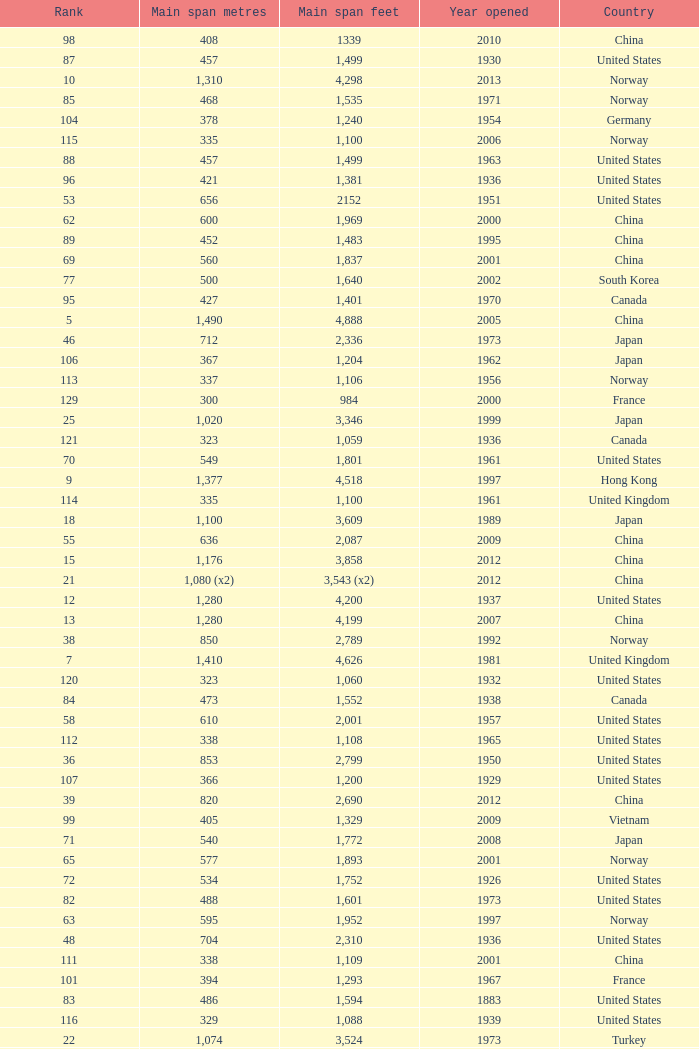Can you parse all the data within this table? {'header': ['Rank', 'Main span metres', 'Main span feet', 'Year opened', 'Country'], 'rows': [['98', '408', '1339', '2010', 'China'], ['87', '457', '1,499', '1930', 'United States'], ['10', '1,310', '4,298', '2013', 'Norway'], ['85', '468', '1,535', '1971', 'Norway'], ['104', '378', '1,240', '1954', 'Germany'], ['115', '335', '1,100', '2006', 'Norway'], ['88', '457', '1,499', '1963', 'United States'], ['96', '421', '1,381', '1936', 'United States'], ['53', '656', '2152', '1951', 'United States'], ['62', '600', '1,969', '2000', 'China'], ['89', '452', '1,483', '1995', 'China'], ['69', '560', '1,837', '2001', 'China'], ['77', '500', '1,640', '2002', 'South Korea'], ['95', '427', '1,401', '1970', 'Canada'], ['5', '1,490', '4,888', '2005', 'China'], ['46', '712', '2,336', '1973', 'Japan'], ['106', '367', '1,204', '1962', 'Japan'], ['113', '337', '1,106', '1956', 'Norway'], ['129', '300', '984', '2000', 'France'], ['25', '1,020', '3,346', '1999', 'Japan'], ['121', '323', '1,059', '1936', 'Canada'], ['70', '549', '1,801', '1961', 'United States'], ['9', '1,377', '4,518', '1997', 'Hong Kong'], ['114', '335', '1,100', '1961', 'United Kingdom'], ['18', '1,100', '3,609', '1989', 'Japan'], ['55', '636', '2,087', '2009', 'China'], ['15', '1,176', '3,858', '2012', 'China'], ['21', '1,080 (x2)', '3,543 (x2)', '2012', 'China'], ['12', '1,280', '4,200', '1937', 'United States'], ['13', '1,280', '4,199', '2007', 'China'], ['38', '850', '2,789', '1992', 'Norway'], ['7', '1,410', '4,626', '1981', 'United Kingdom'], ['120', '323', '1,060', '1932', 'United States'], ['84', '473', '1,552', '1938', 'Canada'], ['58', '610', '2,001', '1957', 'United States'], ['112', '338', '1,108', '1965', 'United States'], ['36', '853', '2,799', '1950', 'United States'], ['107', '366', '1,200', '1929', 'United States'], ['39', '820', '2,690', '2012', 'China'], ['99', '405', '1,329', '2009', 'Vietnam'], ['71', '540', '1,772', '2008', 'Japan'], ['65', '577', '1,893', '2001', 'Norway'], ['72', '534', '1,752', '1926', 'United States'], ['82', '488', '1,601', '1973', 'United States'], ['63', '595', '1,952', '1997', 'Norway'], ['48', '704', '2,310', '1936', 'United States'], ['111', '338', '1,109', '2001', 'China'], ['101', '394', '1,293', '1967', 'France'], ['83', '486', '1,594', '1883', 'United States'], ['116', '329', '1,088', '1939', 'United States'], ['22', '1,074', '3,524', '1973', 'Turkey'], ['119', '325', '1,066', '1981', 'Norway'], ['78', '497', '1,631', '1924', 'United States'], ['109', '350', '1,148', '2006', 'China'], ['86', '465', '1,526', '1977', 'Japan'], ['40', '770', '2,526', '1983', 'Japan'], ['20', '1,088', '3,570', '2009', 'China'], ['90', '450', '1,476', '1997', 'China'], ['67', '564', '1,850', '1929', 'United States Canada'], ['64', '580', '1,903', '2003', 'China'], ['57', '616', '2,021', '2009', 'China'], ['130', '300', '984', '2000', 'South Korea'], ['80', '488', '1,601', '1969', 'United States'], ['92', '446', '1,463', '1997', 'Norway'], ['60', '600', '1,969', '1970', 'Denmark'], ['127', '300', '985', '1961', 'Canada'], ['31', '940', '3,084', '1988', 'Japan'], ['76', '500', '1,640', '1965', 'Germany'], ['16', '1,158', '3,799', '1957', 'United States'], ['37', '853', '2,799', '2007', 'United States'], ['74', '525', '1,722', '1977', 'Norway'], ['17', '1,108', '3,635', '2008', 'China'], ['33', '900', '2,953', '2009', 'China'], ['3', '1,624', '5,328', '1998', 'Denmark'], ['45', '712', '2,336', '1967', 'Venezuela'], ['14', '1,210', '3,970', '1997', 'Sweden'], ['24', '1,030', '3,379', '1999', 'Japan'], ['59', '608', '1,995', '1959', 'France'], ['103', '385', '1,263', '2013', 'United States'], ['66', '570', '1,870', '1993', 'Japan'], ['79', '488', '1,601', '1903', 'United States'], ['28', '990', '3,248', '1988', 'Japan'], ['8', '1,385', '4,544', '1999', 'China'], ['32', '900', '2,953', '1996', 'China'], ['97', '417', '1,368', '1966', 'Sweden'], ['52', '656', '2,152', '1968', 'United States'], ['126', '308', '1,010', '1849', 'United States'], ['68', '560', '1,837', '1988', 'Japan'], ['47', '704', '2,310', '1936', 'United States'], ['102', '390', '1,280', '1964', 'Uzbekistan'], ['42', '750', '2,461', '2000', 'Kazakhstan'], ['29', '988', '3,241', '1966', 'United Kingdom'], ['91', '448', '1,470', '1909', 'United States'], ['81', '488', '1,601', '1952', 'United States'], ['4', '1,545', '5,069', '2012', 'South Korea'], ['54', '648', '2,126', '1999', 'China'], ['61', '600', '1,969', '1999', 'Japan'], ['41', '750', '2,461', '2000', 'Japan'], ['44', '720', '2,362', '1998', 'Japan'], ['75', '520', '1,706', '1983', 'Democratic Republic of the Congo'], ['51', '668', '2,192', '1969', 'Canada'], ['73', '525', '1,722', '1972', 'Norway'], ['128', '300', '984', '1987', 'Japan'], ['19', '1,090', '3,576', '1988', 'Turkey'], ['35', '876', '2,874', '1985', 'Japan'], ['34', '888', '2,913', '1997', 'China'], ['105', '368', '1,207', '1931', 'United States'], ['110', '340', '1,115', '1926', 'Brazil'], ['50', '677', '2,221', '2001', 'Norway'], ['124', '320', '1,050', '2011', 'Peru'], ['125', '315', '1,033', '1951', 'Germany'], ['30', '960', '3,150', '2001', 'China'], ['6', '1,418', '4,652', '2012', 'China'], ['118', '325', '1,066', '1964', 'Norway'], ['2', '1,650', '5,413', '2009', 'China'], ['100', '404', '1,325', '1973', 'South Korea'], ['117', '328', '1,085', '1939', 'Zambia Zimbabwe'], ['93', '441', '1,447', '1955', 'Canada'], ['26', '1,013', '3,323', '1966', 'Portugal'], ['94', '430', '1,411', '2012', 'China'], ['108', '351', '1,151', '1960', 'United States Canada'], ['27', '1,006', '3,301', '1964', 'United Kingdom'], ['43', '728', '2,388', '2003', 'United States'], ['123', '320', '1,050', '1971', 'United States'], ['122', '322', '1,057', '1867', 'United States'], ['23', '1,067', '3,501', '1931', 'United States'], ['1', '1,991', '6,532', '1998', 'Japan'], ['49', '701', '2,300', '1939', 'United States'], ['11', '1,298', '4,260', '1964', 'United States'], ['56', '623', '2,044', '1992', 'Norway']]} What is the main span feet from opening year of 1936 in the United States with a rank greater than 47 and 421 main span metres? 1381.0. 